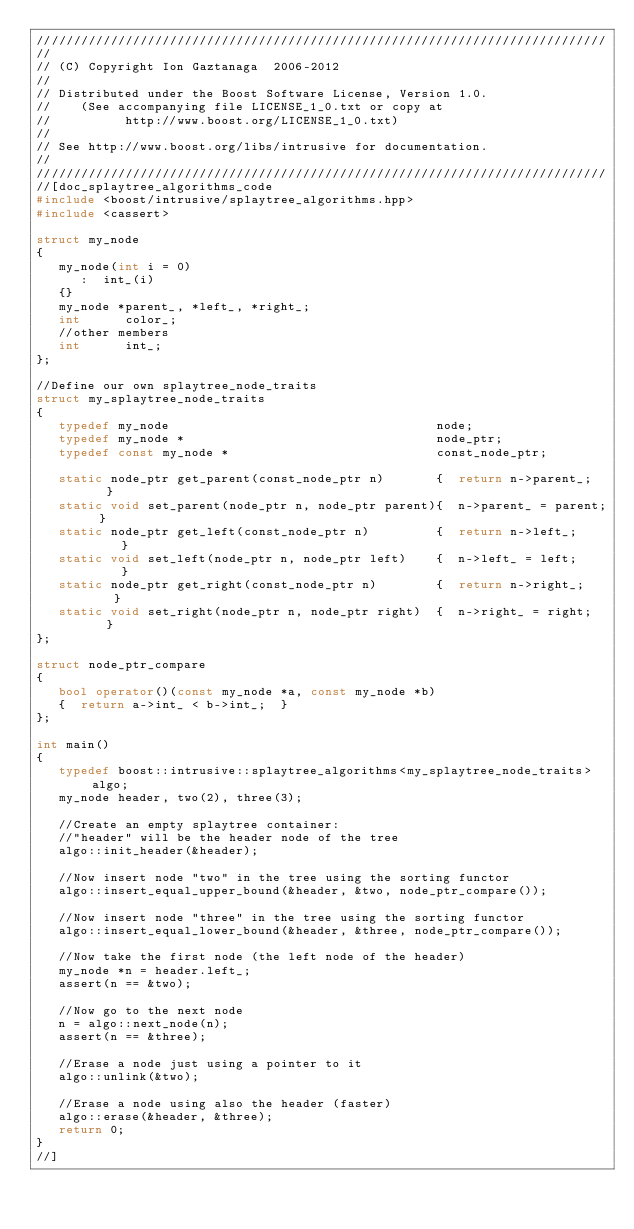<code> <loc_0><loc_0><loc_500><loc_500><_C++_>/////////////////////////////////////////////////////////////////////////////
//
// (C) Copyright Ion Gaztanaga  2006-2012
//
// Distributed under the Boost Software License, Version 1.0.
//    (See accompanying file LICENSE_1_0.txt or copy at
//          http://www.boost.org/LICENSE_1_0.txt)
//
// See http://www.boost.org/libs/intrusive for documentation.
//
/////////////////////////////////////////////////////////////////////////////
//[doc_splaytree_algorithms_code
#include <boost/intrusive/splaytree_algorithms.hpp>
#include <cassert>

struct my_node
{
   my_node(int i = 0)
      :  int_(i)
   {}
   my_node *parent_, *left_, *right_;
   int      color_;
   //other members
   int      int_;
};

//Define our own splaytree_node_traits
struct my_splaytree_node_traits
{
   typedef my_node                                    node;
   typedef my_node *                                  node_ptr;
   typedef const my_node *                            const_node_ptr;

   static node_ptr get_parent(const_node_ptr n)       {  return n->parent_;   }
   static void set_parent(node_ptr n, node_ptr parent){  n->parent_ = parent; }
   static node_ptr get_left(const_node_ptr n)         {  return n->left_;     }
   static void set_left(node_ptr n, node_ptr left)    {  n->left_ = left;     }
   static node_ptr get_right(const_node_ptr n)        {  return n->right_;    }
   static void set_right(node_ptr n, node_ptr right)  {  n->right_ = right;   }
};

struct node_ptr_compare
{
   bool operator()(const my_node *a, const my_node *b)
   {  return a->int_ < b->int_;  }
};

int main()
{
   typedef boost::intrusive::splaytree_algorithms<my_splaytree_node_traits> algo;
   my_node header, two(2), three(3);

   //Create an empty splaytree container:
   //"header" will be the header node of the tree
   algo::init_header(&header);

   //Now insert node "two" in the tree using the sorting functor
   algo::insert_equal_upper_bound(&header, &two, node_ptr_compare());

   //Now insert node "three" in the tree using the sorting functor
   algo::insert_equal_lower_bound(&header, &three, node_ptr_compare());

   //Now take the first node (the left node of the header)
   my_node *n = header.left_;
   assert(n == &two);

   //Now go to the next node
   n = algo::next_node(n);
   assert(n == &three);

   //Erase a node just using a pointer to it
   algo::unlink(&two);

   //Erase a node using also the header (faster)
   algo::erase(&header, &three);
   return 0;
}
//]
</code> 